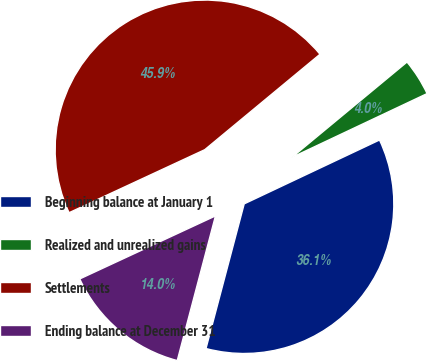Convert chart to OTSL. <chart><loc_0><loc_0><loc_500><loc_500><pie_chart><fcel>Beginning balance at January 1<fcel>Realized and unrealized gains<fcel>Settlements<fcel>Ending balance at December 31<nl><fcel>36.13%<fcel>3.99%<fcel>45.91%<fcel>13.97%<nl></chart> 